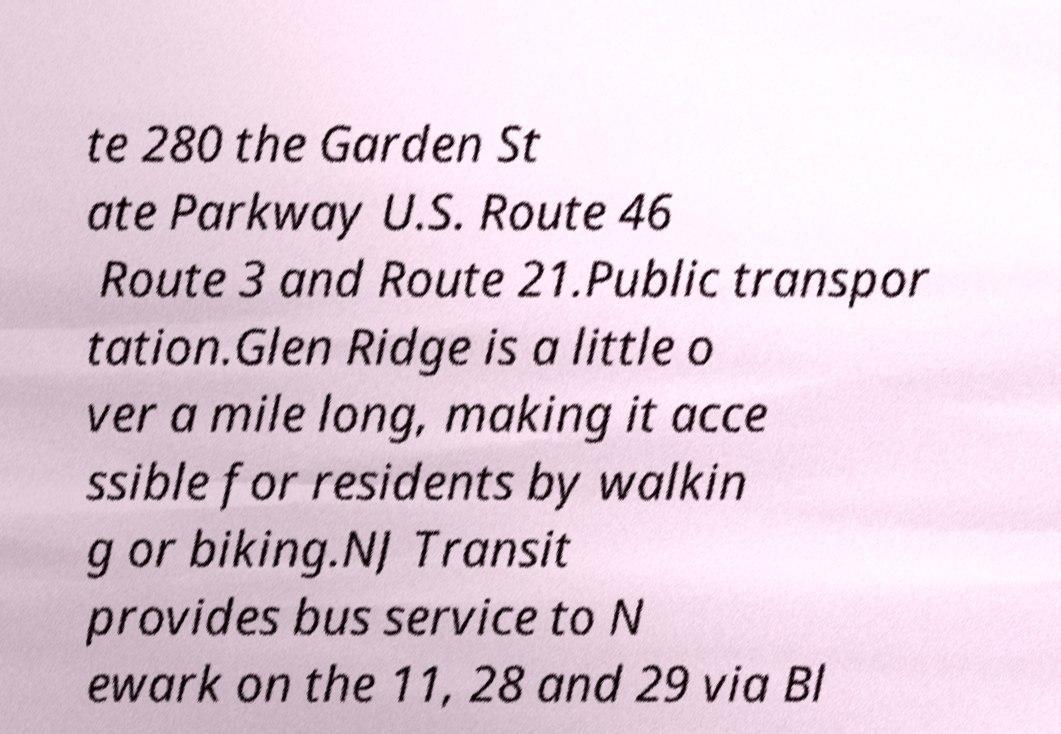I need the written content from this picture converted into text. Can you do that? te 280 the Garden St ate Parkway U.S. Route 46 Route 3 and Route 21.Public transpor tation.Glen Ridge is a little o ver a mile long, making it acce ssible for residents by walkin g or biking.NJ Transit provides bus service to N ewark on the 11, 28 and 29 via Bl 